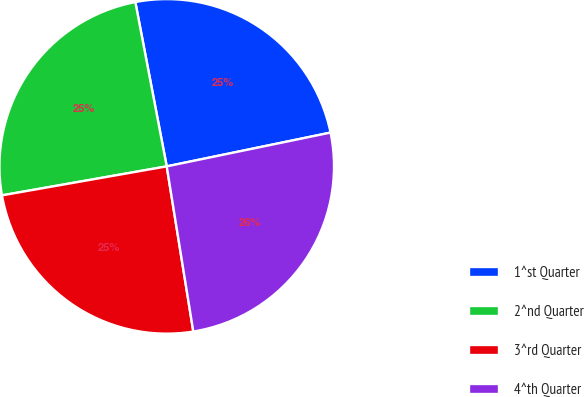Convert chart to OTSL. <chart><loc_0><loc_0><loc_500><loc_500><pie_chart><fcel>1^st Quarter<fcel>2^nd Quarter<fcel>3^rd Quarter<fcel>4^th Quarter<nl><fcel>24.77%<fcel>24.77%<fcel>24.77%<fcel>25.7%<nl></chart> 